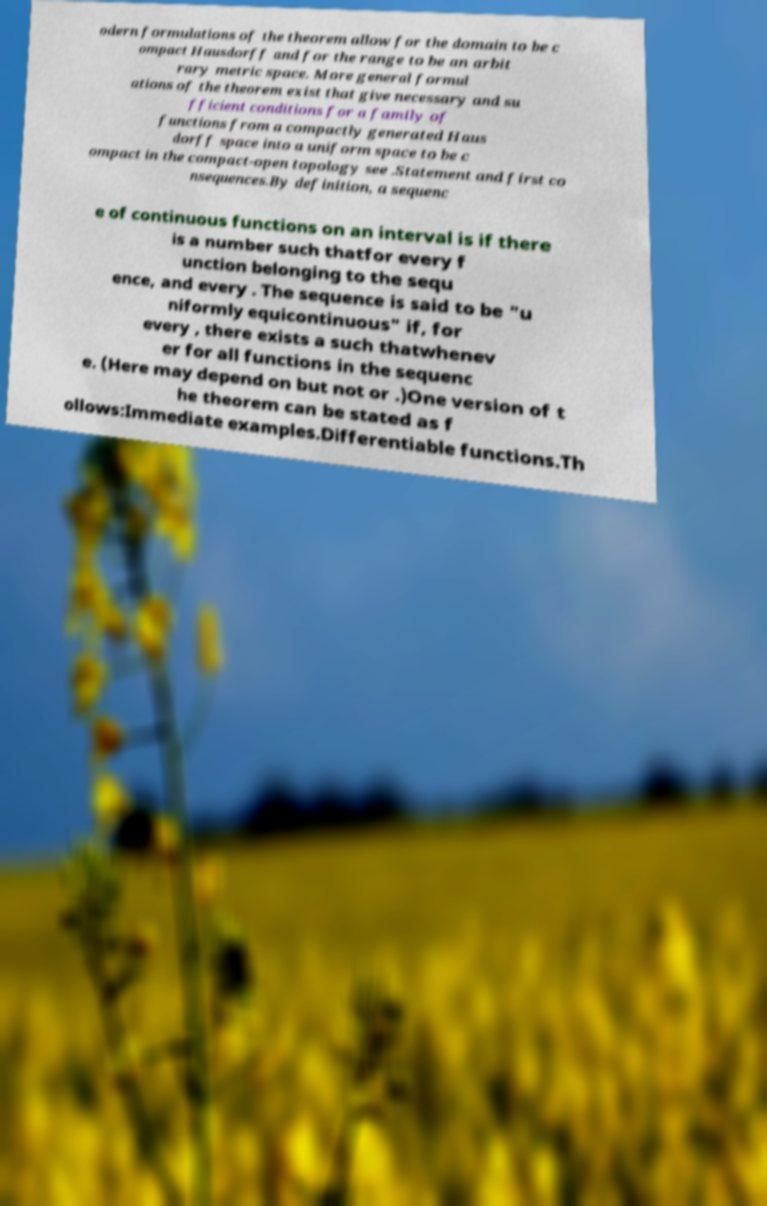Please read and relay the text visible in this image. What does it say? odern formulations of the theorem allow for the domain to be c ompact Hausdorff and for the range to be an arbit rary metric space. More general formul ations of the theorem exist that give necessary and su fficient conditions for a family of functions from a compactly generated Haus dorff space into a uniform space to be c ompact in the compact-open topology see .Statement and first co nsequences.By definition, a sequenc e of continuous functions on an interval is if there is a number such thatfor every f unction belonging to the sequ ence, and every . The sequence is said to be "u niformly equicontinuous" if, for every , there exists a such thatwhenev er for all functions in the sequenc e. (Here may depend on but not or .)One version of t he theorem can be stated as f ollows:Immediate examples.Differentiable functions.Th 